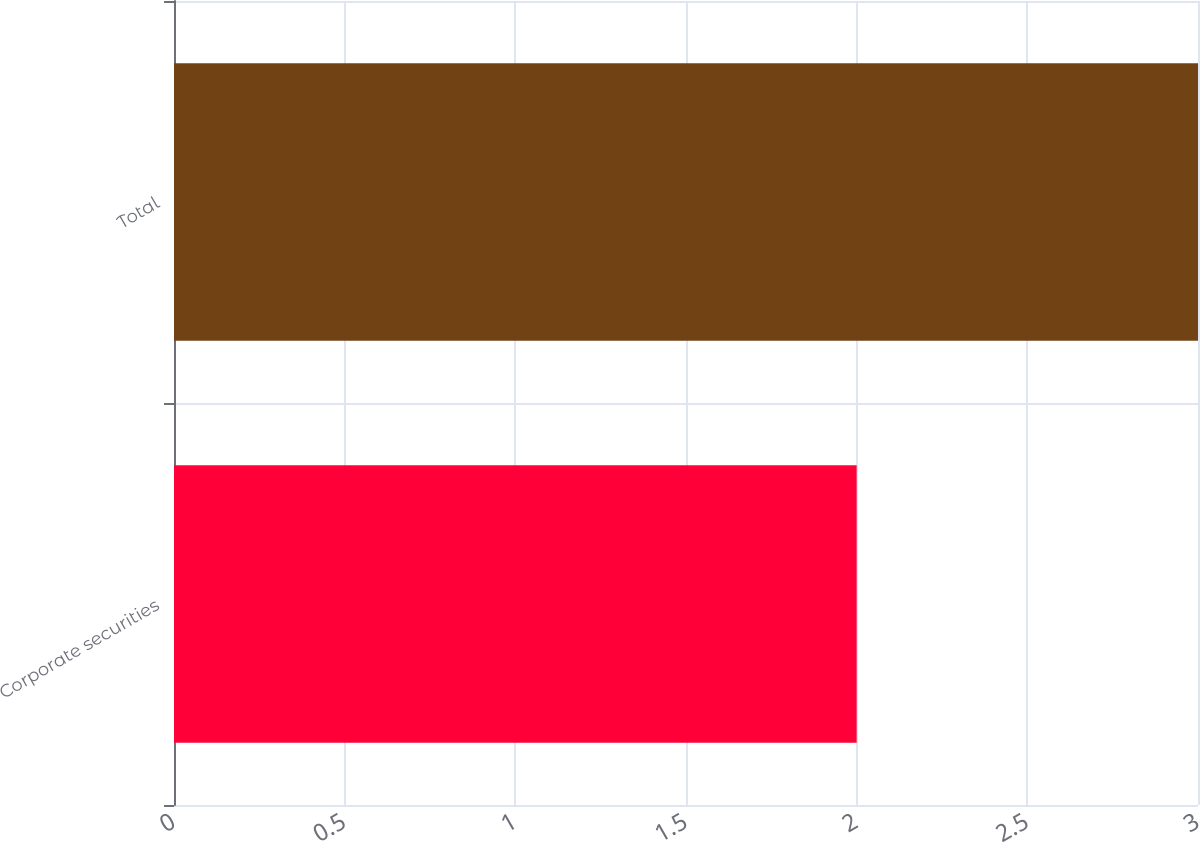Convert chart to OTSL. <chart><loc_0><loc_0><loc_500><loc_500><bar_chart><fcel>Corporate securities<fcel>Total<nl><fcel>2<fcel>3<nl></chart> 